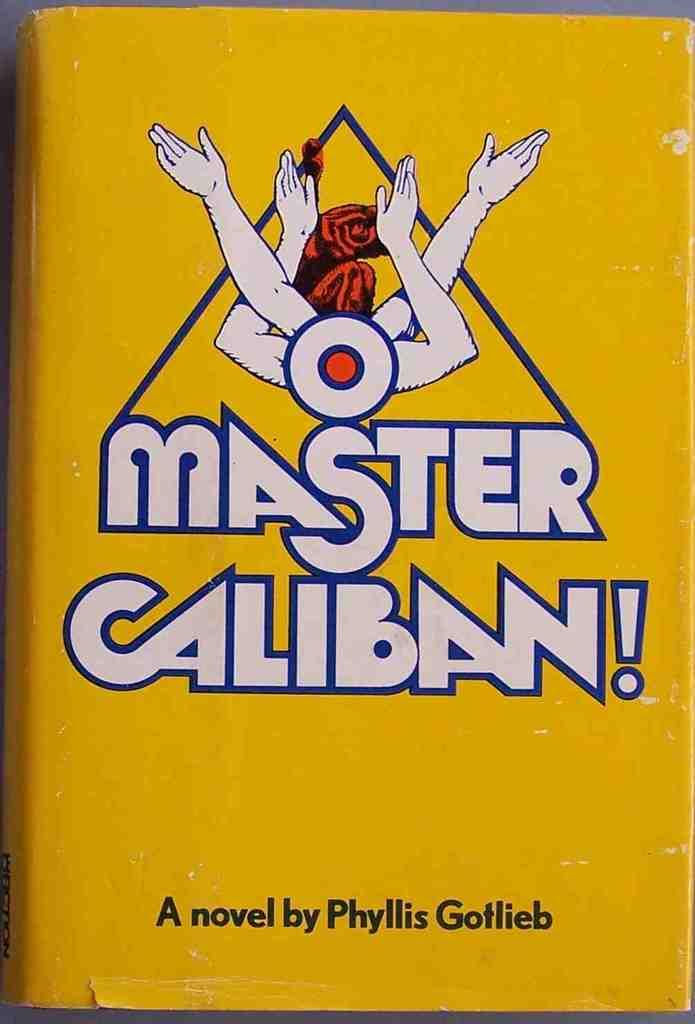<image>
Share a concise interpretation of the image provided. Master Cabin novel by Phyllis Gotlieb yellow book. 